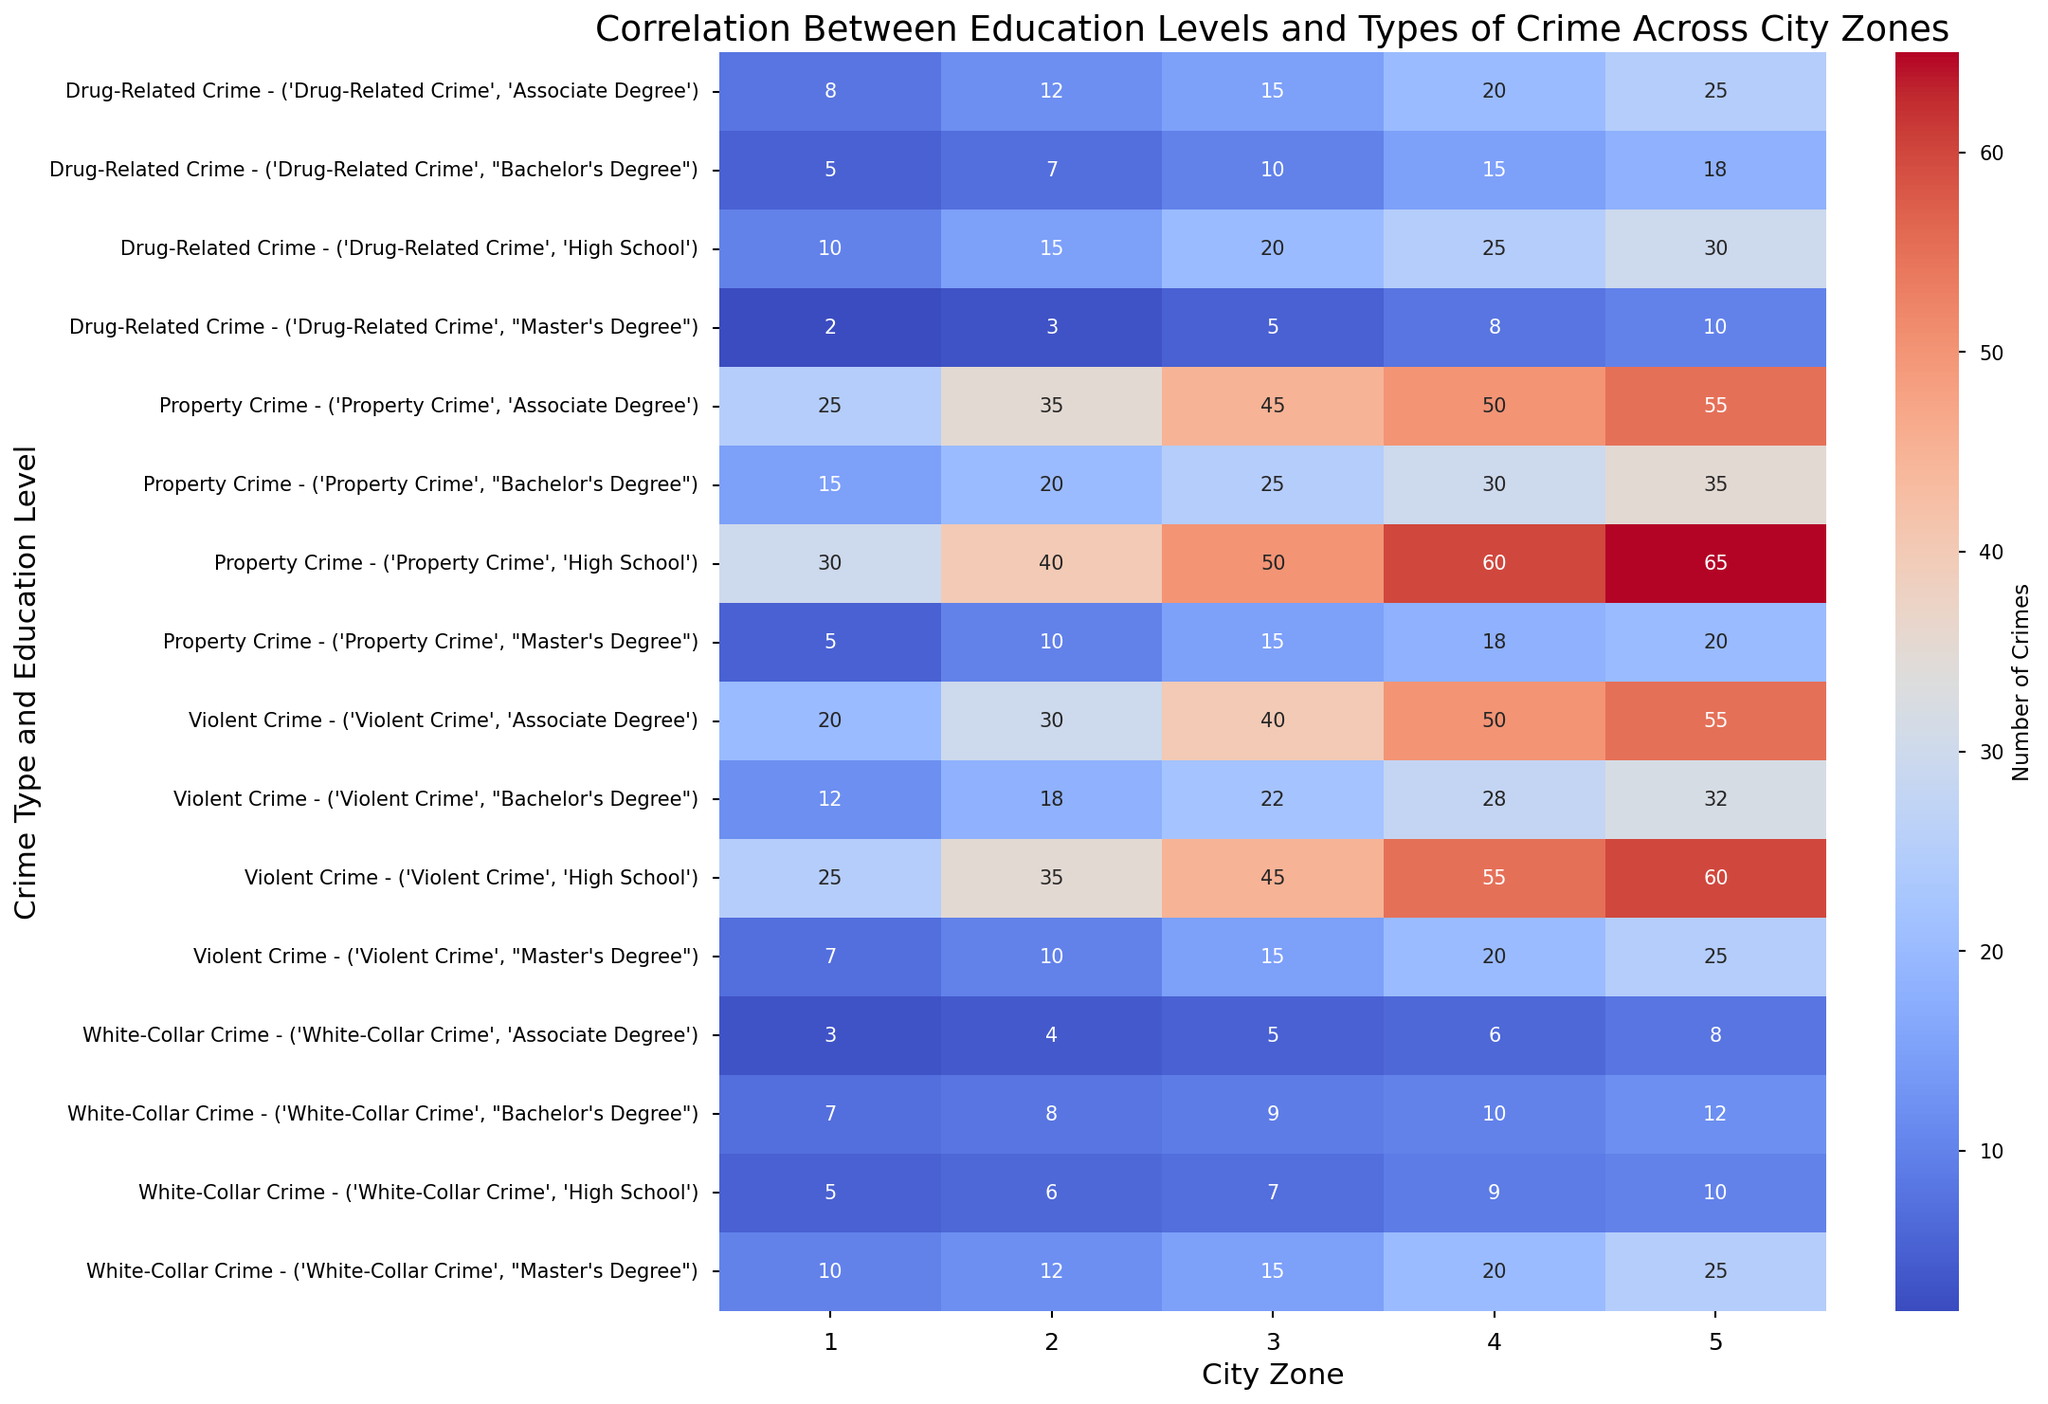Which city zone has the highest number of property crimes overall? By summing up the property crimes for all education levels within each city zone, we find that Zone 5 (High School: 65, Associate Degree: 55, Bachelor's Degree: 35, Master's Degree: 20) has the highest total of 175 property crimes.
Answer: Zone 5 How do property crimes in City Zone 3 compare between high school and master’s degree education levels? In City Zone 3, property crimes for high school level are 50, whereas for master’s degree level they are 15, demonstrating a significant decrease.
Answer: High school What is the average number of drug-related crimes in City Zone 1 for all education levels? The data for drug-related crimes in City Zone 1 reads as follows: High School: 10, Associate Degree: 8, Bachelor's Degree: 5, Master's Degree: 2. The average is calculated as (10+8+5+2)/4 = 25/4 = 6.25.
Answer: 6.25 Which education level has the most white-collar crimes in City Zone 5? The data for white-collar crimes in Zone 5 is given as: High School: 10, Associate Degree: 8, Bachelor's Degree: 12, Master's Degree: 25. The highest value is 25 for Master's Degree.
Answer: Master’s Degree In which city zone do violent crimes peak for those with a Bachelor's degree? Checking the violent crimes across all city zones for Bachelor's degree holders, we see the values are Zone 1: 12, Zone 2: 18, Zone 3: 22, Zone 4: 28, and Zone 5: 32. City Zone 5 has the highest value at 32.
Answer: Zone 5 What is the difference between the number of violent crimes in Zone 2 and Zone 4 among those with an associate degree? In Zone 2, there are 30 violent crimes for those with an associate degree, and in Zone 4, there are 50. The difference is 50 - 30 = 20.
Answer: 20 Which type of crime shows the most reduction as the education level increases within City Zone 4? By visually examining the heatmap and comparing crimes across education levels within City Zone 4, property crimes decrease the most from 60 (High School) to 18 (Master's Degree), showing the largest reduction.
Answer: Property Crime What is the combined number of white-collar crimes in City Zones 1 and 2 for Bachelor's degree holders? The white-collar crimes for Bachelor's degrees are 7 for Zone 1 and 8 for Zone 2. The combined total is 7 + 8 = 15.
Answer: 15 Is there any city zone where drug-related crimes increase as education levels go up? By inspecting the heatmap, Zone 5 exhibits an increase: High School: 30, Associate Degree: 25, Bachelor's Degree: 18, Master's Degree: 10, so no zone demonstrates an increase with higher education levels.
Answer: No Which crime type is consistently highest for all education levels in City Zone 5? By examining the data for all education levels in Zone 5, property crimes (values: High School: 65, Associate Degree: 55, Bachelor's Degree: 35, Master's Degree: 20) are consistently the highest among all crime types.
Answer: Property Crime 